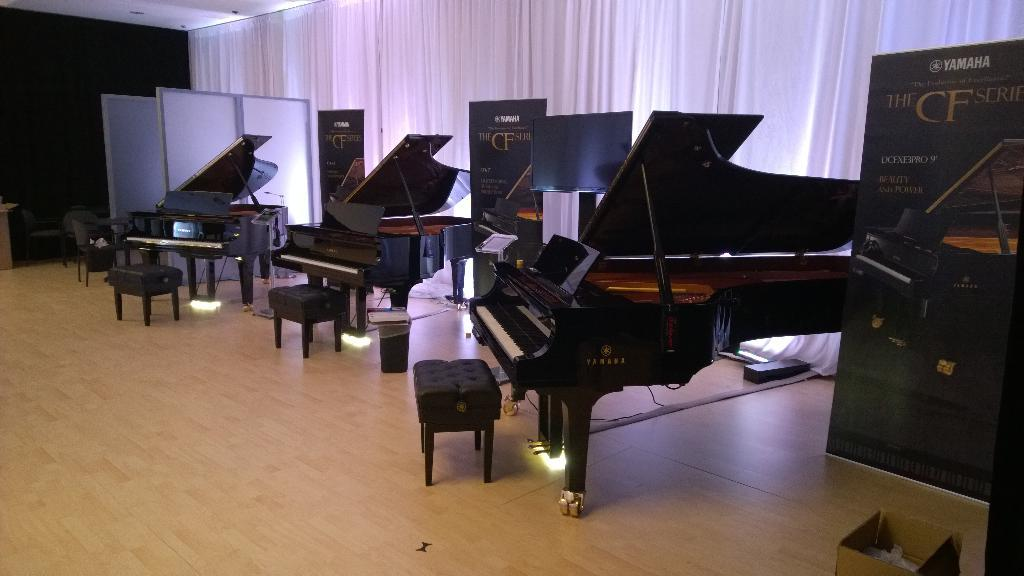How many pianos are in the room? There are three pianos in the room. What type of furniture is present for seating in the room? There are three chairs in the room. Where is the banner located in the room? There is a banner on the right side of the room. How many banners are in the room in total? There are three banners in the room. What color are the curtains in the background? The curtains in the background have a white color. What type of lumber is being used to build the pianos in the image? There is no information about the type of lumber used to build the pianos in the image. What kind of loaf is being served on the table in the image? There is no table or loaf present in the image. 